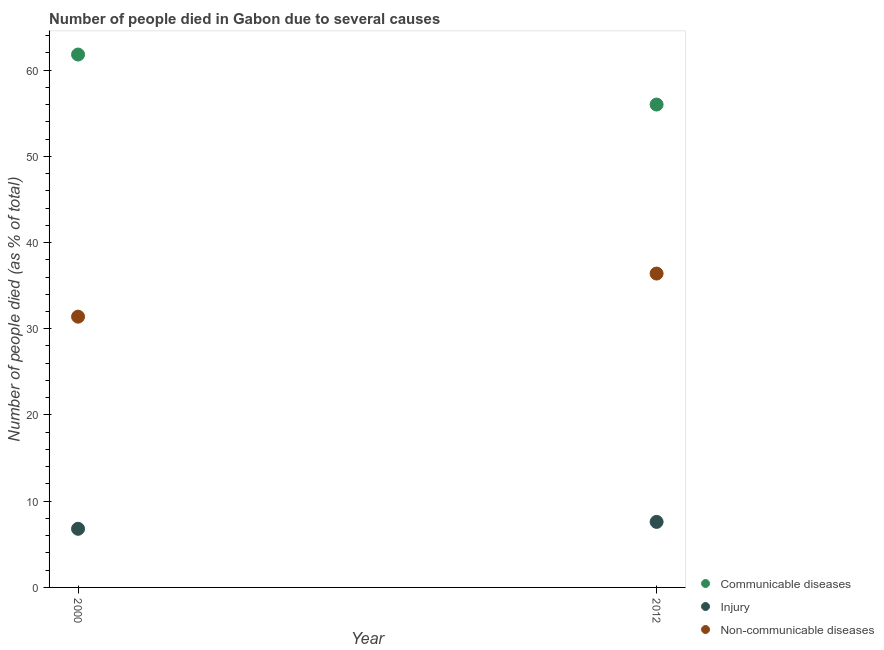How many different coloured dotlines are there?
Offer a terse response. 3. What is the number of people who died of injury in 2000?
Your answer should be compact. 6.8. Across all years, what is the maximum number of people who died of communicable diseases?
Ensure brevity in your answer.  61.8. In which year was the number of people who dies of non-communicable diseases maximum?
Your answer should be compact. 2012. In which year was the number of people who died of communicable diseases minimum?
Your answer should be very brief. 2012. What is the total number of people who died of communicable diseases in the graph?
Provide a short and direct response. 117.8. What is the difference between the number of people who died of injury in 2000 and that in 2012?
Provide a succinct answer. -0.8. What is the difference between the number of people who dies of non-communicable diseases in 2012 and the number of people who died of injury in 2000?
Your answer should be compact. 29.6. What is the average number of people who dies of non-communicable diseases per year?
Give a very brief answer. 33.9. In the year 2012, what is the difference between the number of people who dies of non-communicable diseases and number of people who died of injury?
Offer a very short reply. 28.8. In how many years, is the number of people who dies of non-communicable diseases greater than 42 %?
Provide a short and direct response. 0. What is the ratio of the number of people who died of injury in 2000 to that in 2012?
Offer a very short reply. 0.89. Is it the case that in every year, the sum of the number of people who died of communicable diseases and number of people who died of injury is greater than the number of people who dies of non-communicable diseases?
Offer a terse response. Yes. Does the number of people who died of injury monotonically increase over the years?
Make the answer very short. Yes. Is the number of people who died of communicable diseases strictly less than the number of people who dies of non-communicable diseases over the years?
Give a very brief answer. No. How many years are there in the graph?
Your response must be concise. 2. What is the difference between two consecutive major ticks on the Y-axis?
Make the answer very short. 10. Does the graph contain grids?
Keep it short and to the point. No. Where does the legend appear in the graph?
Give a very brief answer. Bottom right. How many legend labels are there?
Give a very brief answer. 3. How are the legend labels stacked?
Your answer should be compact. Vertical. What is the title of the graph?
Your answer should be very brief. Number of people died in Gabon due to several causes. Does "Primary education" appear as one of the legend labels in the graph?
Your answer should be very brief. No. What is the label or title of the Y-axis?
Give a very brief answer. Number of people died (as % of total). What is the Number of people died (as % of total) of Communicable diseases in 2000?
Your answer should be very brief. 61.8. What is the Number of people died (as % of total) of Non-communicable diseases in 2000?
Offer a terse response. 31.4. What is the Number of people died (as % of total) of Injury in 2012?
Provide a short and direct response. 7.6. What is the Number of people died (as % of total) in Non-communicable diseases in 2012?
Keep it short and to the point. 36.4. Across all years, what is the maximum Number of people died (as % of total) in Communicable diseases?
Keep it short and to the point. 61.8. Across all years, what is the maximum Number of people died (as % of total) of Injury?
Your answer should be very brief. 7.6. Across all years, what is the maximum Number of people died (as % of total) in Non-communicable diseases?
Provide a short and direct response. 36.4. Across all years, what is the minimum Number of people died (as % of total) of Communicable diseases?
Make the answer very short. 56. Across all years, what is the minimum Number of people died (as % of total) in Injury?
Keep it short and to the point. 6.8. Across all years, what is the minimum Number of people died (as % of total) of Non-communicable diseases?
Your answer should be very brief. 31.4. What is the total Number of people died (as % of total) of Communicable diseases in the graph?
Keep it short and to the point. 117.8. What is the total Number of people died (as % of total) in Injury in the graph?
Keep it short and to the point. 14.4. What is the total Number of people died (as % of total) in Non-communicable diseases in the graph?
Provide a short and direct response. 67.8. What is the difference between the Number of people died (as % of total) of Non-communicable diseases in 2000 and that in 2012?
Your answer should be compact. -5. What is the difference between the Number of people died (as % of total) in Communicable diseases in 2000 and the Number of people died (as % of total) in Injury in 2012?
Give a very brief answer. 54.2. What is the difference between the Number of people died (as % of total) in Communicable diseases in 2000 and the Number of people died (as % of total) in Non-communicable diseases in 2012?
Offer a very short reply. 25.4. What is the difference between the Number of people died (as % of total) in Injury in 2000 and the Number of people died (as % of total) in Non-communicable diseases in 2012?
Offer a very short reply. -29.6. What is the average Number of people died (as % of total) in Communicable diseases per year?
Ensure brevity in your answer.  58.9. What is the average Number of people died (as % of total) of Injury per year?
Your answer should be compact. 7.2. What is the average Number of people died (as % of total) of Non-communicable diseases per year?
Ensure brevity in your answer.  33.9. In the year 2000, what is the difference between the Number of people died (as % of total) in Communicable diseases and Number of people died (as % of total) in Non-communicable diseases?
Your answer should be compact. 30.4. In the year 2000, what is the difference between the Number of people died (as % of total) of Injury and Number of people died (as % of total) of Non-communicable diseases?
Provide a succinct answer. -24.6. In the year 2012, what is the difference between the Number of people died (as % of total) in Communicable diseases and Number of people died (as % of total) in Injury?
Your answer should be very brief. 48.4. In the year 2012, what is the difference between the Number of people died (as % of total) in Communicable diseases and Number of people died (as % of total) in Non-communicable diseases?
Provide a succinct answer. 19.6. In the year 2012, what is the difference between the Number of people died (as % of total) of Injury and Number of people died (as % of total) of Non-communicable diseases?
Offer a very short reply. -28.8. What is the ratio of the Number of people died (as % of total) in Communicable diseases in 2000 to that in 2012?
Make the answer very short. 1.1. What is the ratio of the Number of people died (as % of total) of Injury in 2000 to that in 2012?
Offer a very short reply. 0.89. What is the ratio of the Number of people died (as % of total) of Non-communicable diseases in 2000 to that in 2012?
Provide a short and direct response. 0.86. What is the difference between the highest and the second highest Number of people died (as % of total) in Injury?
Keep it short and to the point. 0.8. What is the difference between the highest and the second highest Number of people died (as % of total) of Non-communicable diseases?
Your answer should be compact. 5. What is the difference between the highest and the lowest Number of people died (as % of total) in Communicable diseases?
Keep it short and to the point. 5.8. What is the difference between the highest and the lowest Number of people died (as % of total) of Injury?
Make the answer very short. 0.8. 